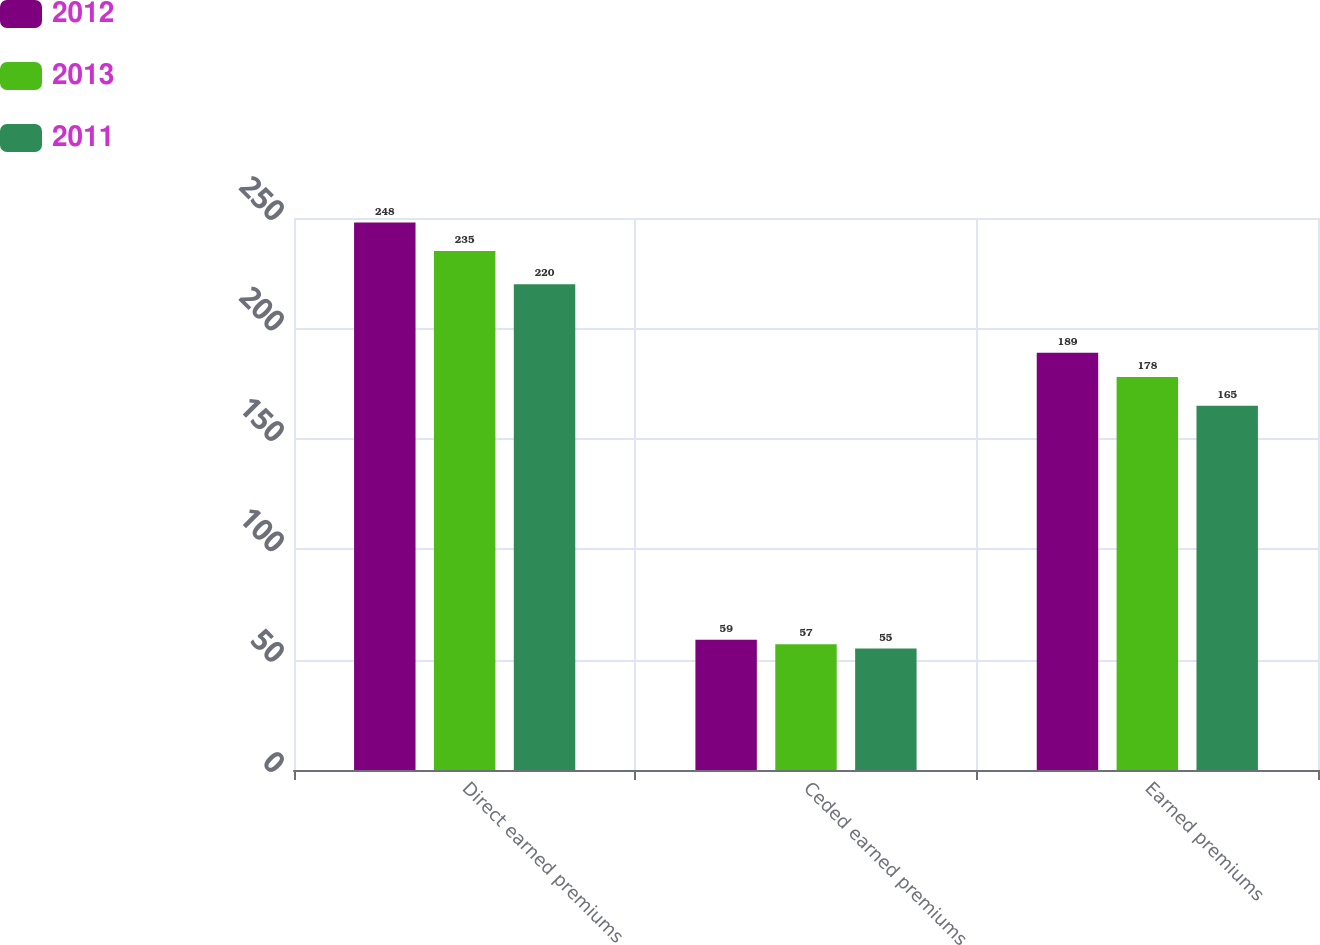Convert chart. <chart><loc_0><loc_0><loc_500><loc_500><stacked_bar_chart><ecel><fcel>Direct earned premiums<fcel>Ceded earned premiums<fcel>Earned premiums<nl><fcel>2012<fcel>248<fcel>59<fcel>189<nl><fcel>2013<fcel>235<fcel>57<fcel>178<nl><fcel>2011<fcel>220<fcel>55<fcel>165<nl></chart> 